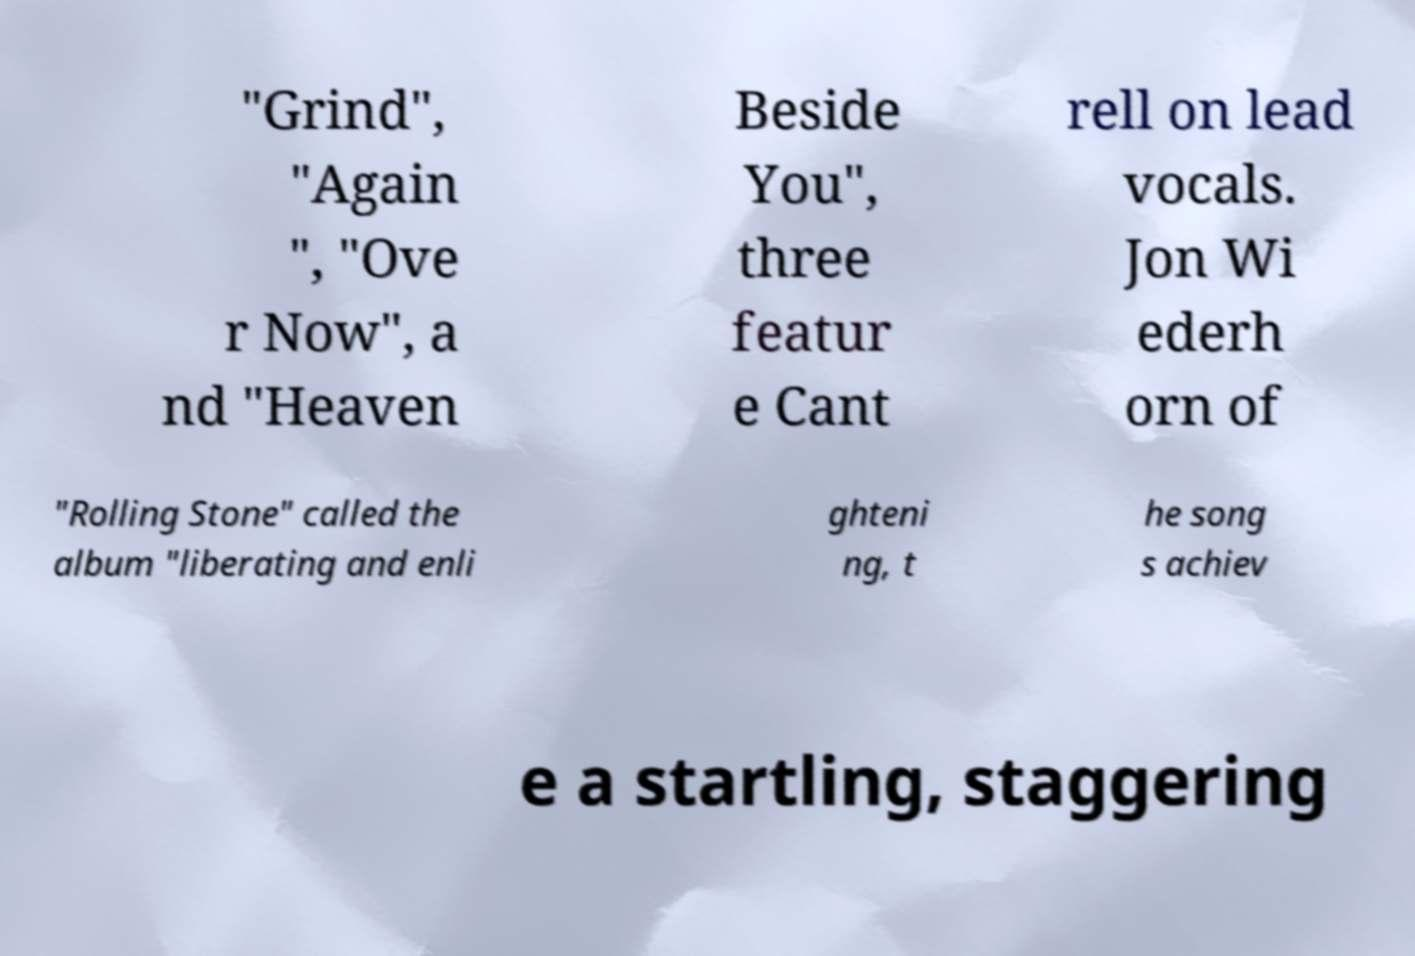Can you accurately transcribe the text from the provided image for me? "Grind", "Again ", "Ove r Now", a nd "Heaven Beside You", three featur e Cant rell on lead vocals. Jon Wi ederh orn of "Rolling Stone" called the album "liberating and enli ghteni ng, t he song s achiev e a startling, staggering 